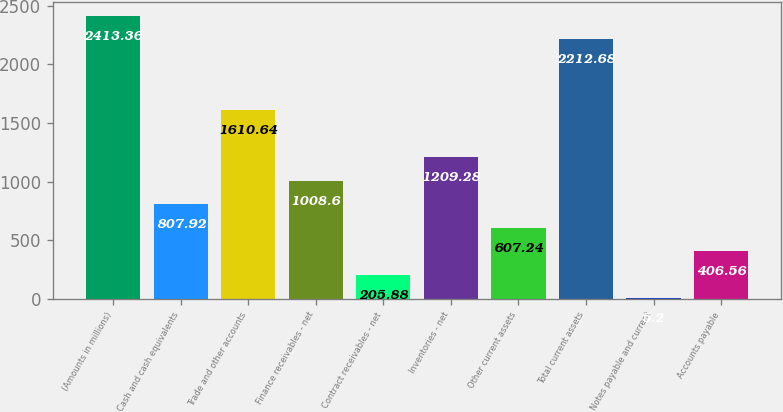<chart> <loc_0><loc_0><loc_500><loc_500><bar_chart><fcel>(Amounts in millions)<fcel>Cash and cash equivalents<fcel>Trade and other accounts<fcel>Finance receivables - net<fcel>Contract receivables - net<fcel>Inventories - net<fcel>Other current assets<fcel>Total current assets<fcel>Notes payable and current<fcel>Accounts payable<nl><fcel>2413.36<fcel>807.92<fcel>1610.64<fcel>1008.6<fcel>205.88<fcel>1209.28<fcel>607.24<fcel>2212.68<fcel>5.2<fcel>406.56<nl></chart> 